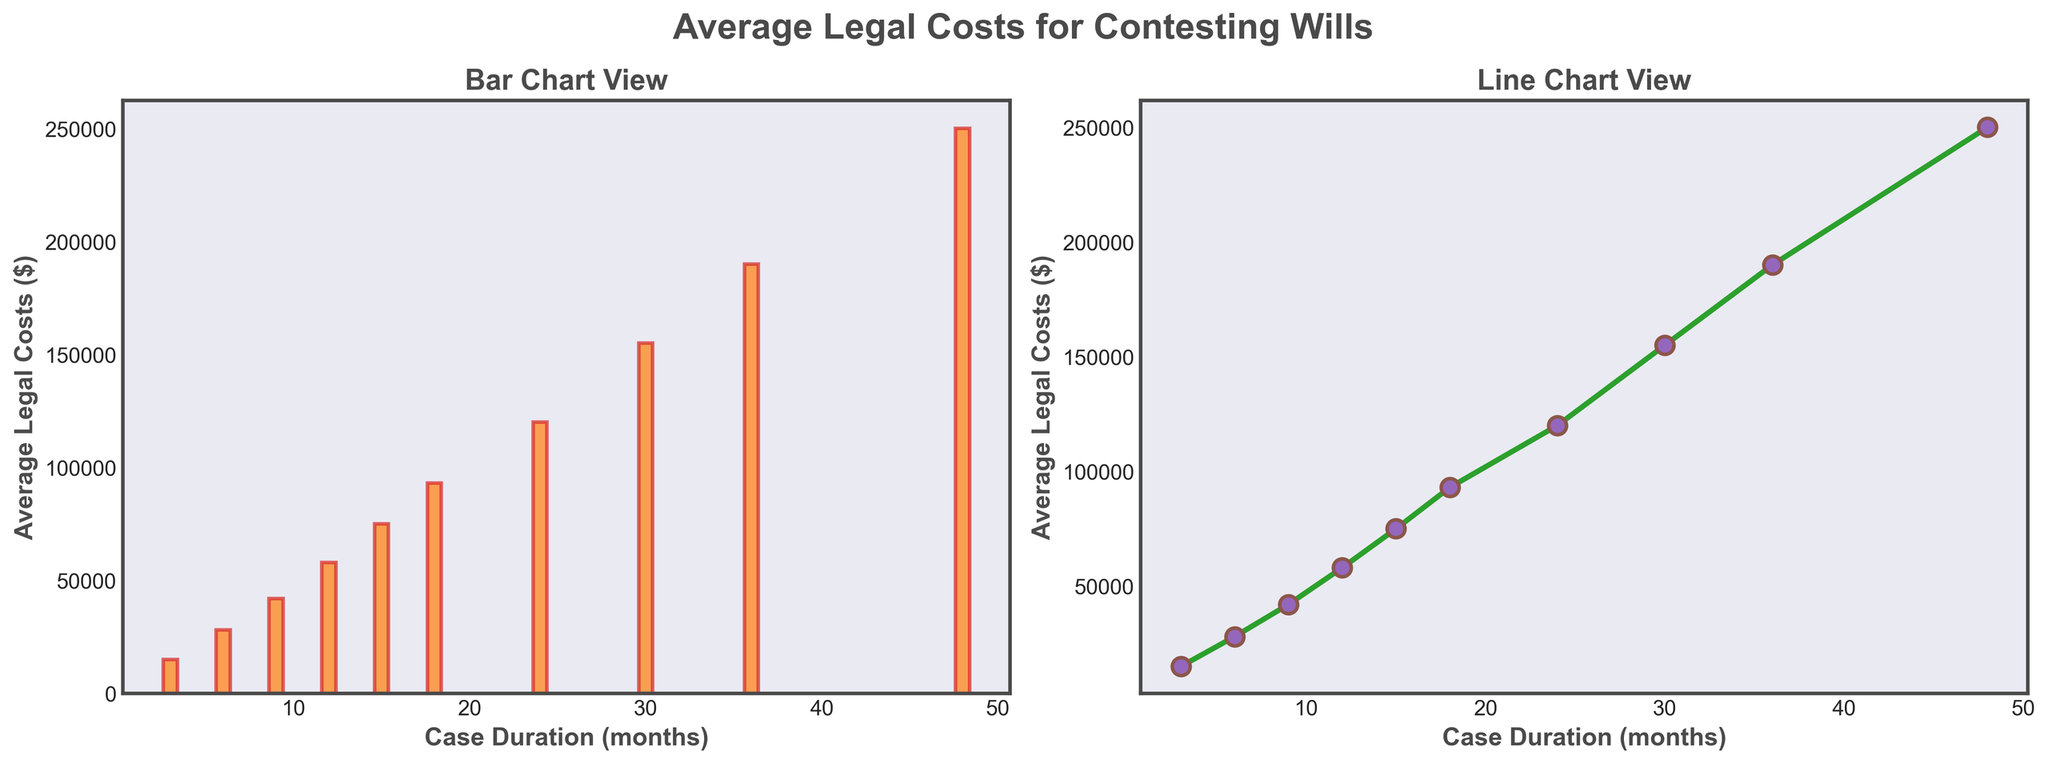What is the average legal cost for a case that lasts 24 months? Refer to the line plot or bar chart: the y-axis value corresponding to 24 months on the x-axis is $120,000.
Answer: $120,000 Which duration has higher average legal costs, 9 months or 18 months? Locate the costs for both durations in the chart and compare: the 9-month cost is $42,000 and the 18-month cost is $93,000. $93,000 is greater than $42,000.
Answer: 18 months What is the total average legal cost for cases lasting 12 months and 36 months combined? Add the average legal costs for 12 months ($58,000) and 36 months ($190,000): $58,000 + $190,000 = $248,000.
Answer: $248,000 If a case duration increases from 3 months to 15 months, by how much does the average legal cost increase? Calculate the difference in costs between 15 months ($75,000) and 3 months ($15,000): $75,000 - $15,000 = $60,000.
Answer: $60,000 What is the average increase in legal costs per month between 18 months and 24 months? Find the cost difference between 24 months ($120,000) and 18 months ($93,000): $120,000 - $93,000 = $27,000. Since the period between is 6 months, divide $27,000 by 6: $27,000 / 6 = $4,500.
Answer: $4,500 per month Identify the duration where the average legal cost is closest to $100,000. Locate the cost values surrounding $100,000: the closest value is $93,000 at 18 months.
Answer: 18 months What is the percentage increase in average legal costs from 6 months to 48 months? Calculate the difference: $250,000 (48 months) - $28,000 (6 months) = $222,000. Then, (difference / initial cost) * 100: ($222,000 / $28,000) * 100 ≈ 793%.
Answer: 793% At what duration do average legal costs exceed $100,000 for the first time? Analyze the chart to see when costs first surpass $100,000. It occurs between 18 months ($93,000) and 24 months ($120,000). Thus, it's at 24 months.
Answer: 24 months What is the average legal cost at the shortest case duration depicted? Locate the value at the shortest duration, 3 months: $15,000.
Answer: $15,000 Compare the bar heights for 12 months and 30 months; which is taller and by how much? Measure both: the bar for 12 months is at $58,000 and for 30 months is at $155,000. The difference is $155,000 - $58,000 = $97,000.
Answer: 30 months, by $97,000 